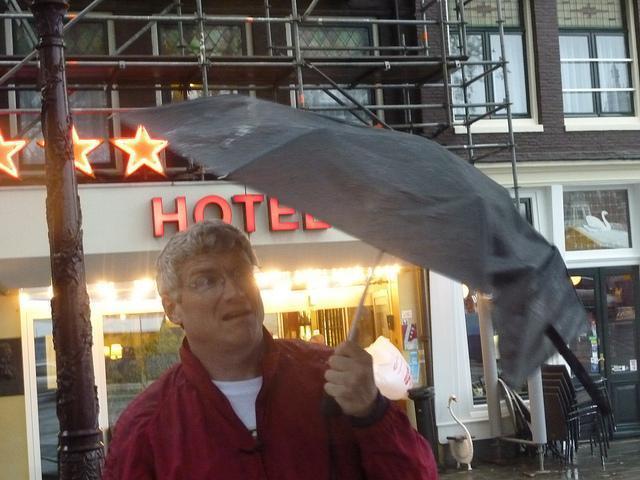Is the given caption "The person is beneath the umbrella." fitting for the image?
Answer yes or no. Yes. Does the caption "The person is below the umbrella." correctly depict the image?
Answer yes or no. Yes. 